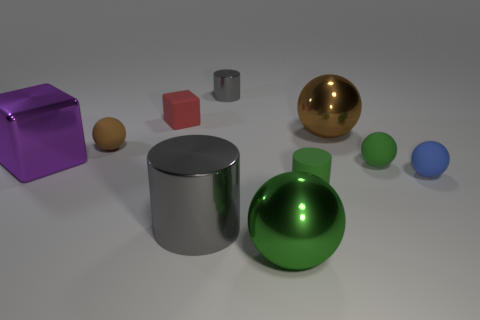How many spheres are both on the right side of the big brown metal thing and in front of the large gray metallic cylinder?
Offer a terse response. 0. Is the number of tiny green rubber objects that are on the left side of the large gray cylinder the same as the number of shiny cubes on the left side of the red rubber object?
Give a very brief answer. No. Is the shape of the brown object left of the big brown shiny ball the same as  the large brown thing?
Give a very brief answer. Yes. What shape is the gray metal object behind the large sphere behind the gray metallic object in front of the brown matte object?
Provide a short and direct response. Cylinder. There is a tiny object that is the same color as the tiny rubber cylinder; what shape is it?
Offer a very short reply. Sphere. There is a object that is on the right side of the big gray cylinder and behind the brown metallic object; what material is it made of?
Your response must be concise. Metal. Is the number of shiny balls less than the number of big purple things?
Make the answer very short. No. Does the tiny red thing have the same shape as the brown thing on the right side of the small red block?
Ensure brevity in your answer.  No. There is a brown thing that is left of the green metal ball; does it have the same size as the big gray metallic object?
Offer a very short reply. No. The green rubber object that is the same size as the green rubber ball is what shape?
Your answer should be very brief. Cylinder. 